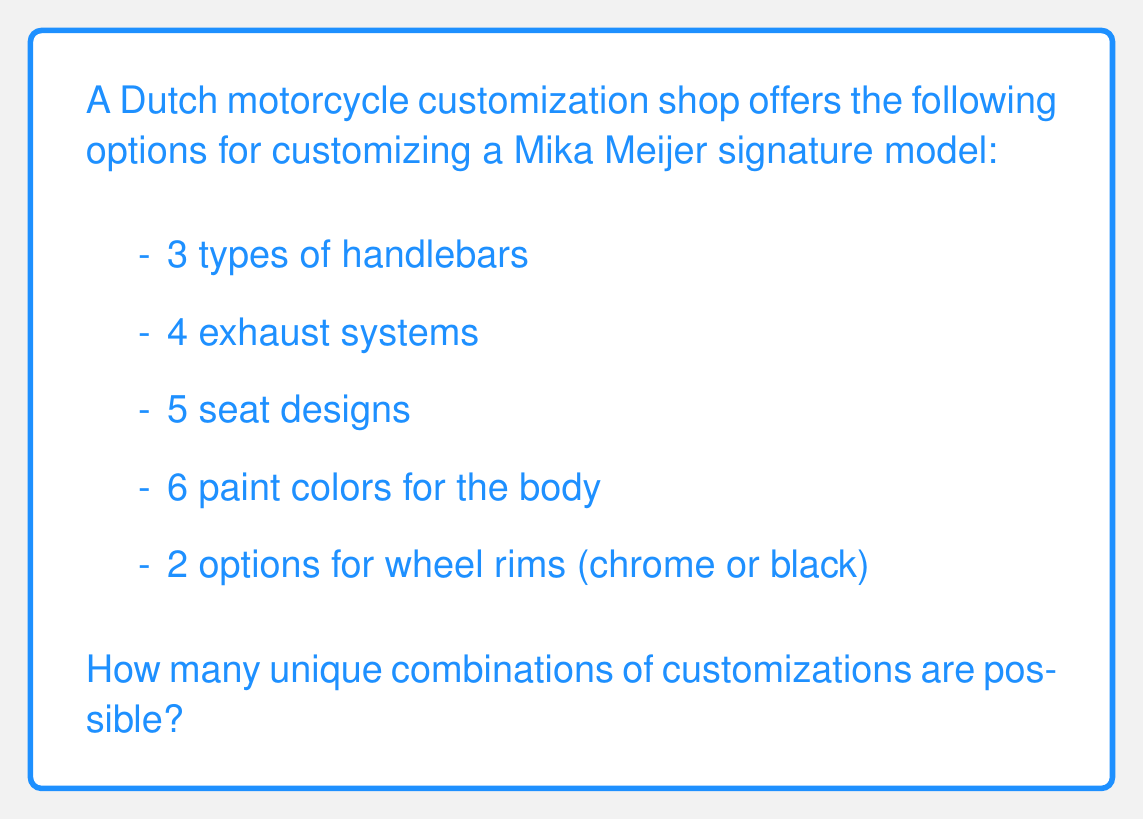Teach me how to tackle this problem. Let's approach this step-by-step using the multiplication principle of combinatorics:

1) For each component, we have independent choices that don't affect the other components. This means we can multiply the number of options for each component to get the total number of combinations.

2) Let's list out the number of options for each component:
   - Handlebars: 3 options
   - Exhaust systems: 4 options
   - Seat designs: 5 options
   - Paint colors: 6 options
   - Wheel rims: 2 options

3) According to the multiplication principle, if we have $m$ ways of doing something and $n$ ways of doing another thing, there are $m \times n$ ways of doing both.

4) Extending this to our five components, we multiply all the options:

   $$ 3 \times 4 \times 5 \times 6 \times 2 $$

5) Let's calculate:
   $$ 3 \times 4 \times 5 \times 6 \times 2 = 720 $$

Therefore, there are 720 unique combinations of customizations possible for the Mika Meijer signature model.
Answer: 720 